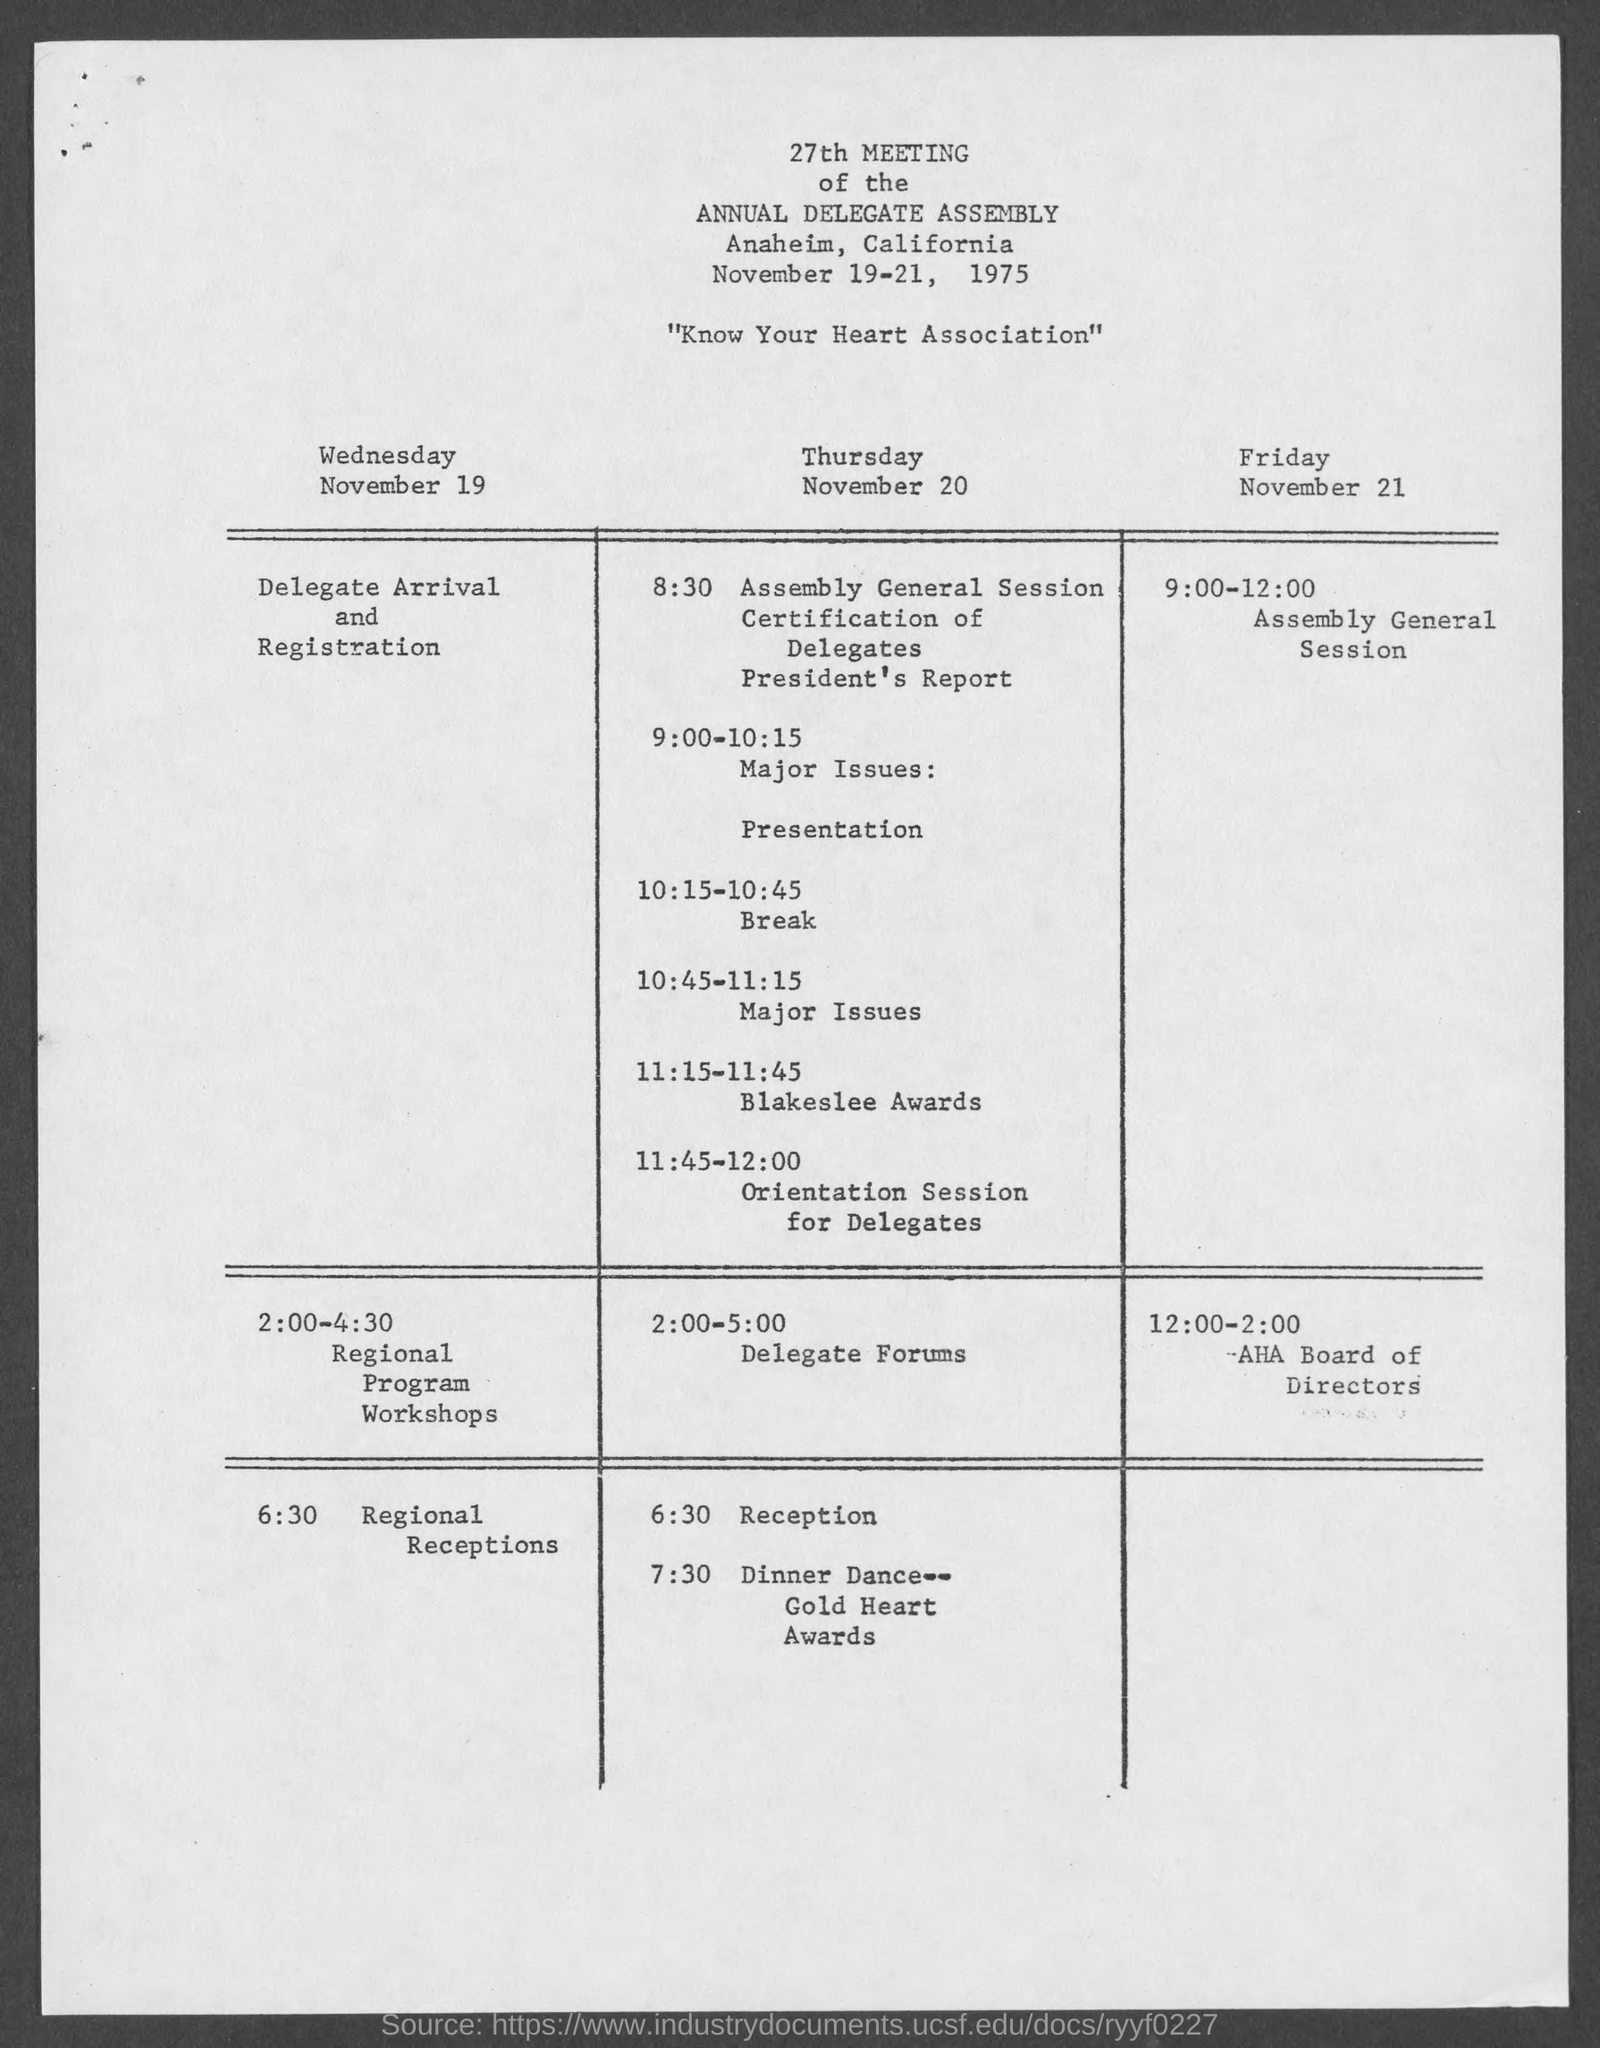What is the title of the document?
Your response must be concise. 27th Meeting of the Annual Delegate Assembly. Registration is on which day?
Give a very brief answer. Wednesday November 19. Gold Heart Awards is on which day?
Your response must be concise. Thursday November 20. Blakeslee Awards is on which day?
Your answer should be very brief. Thursday November 20. 